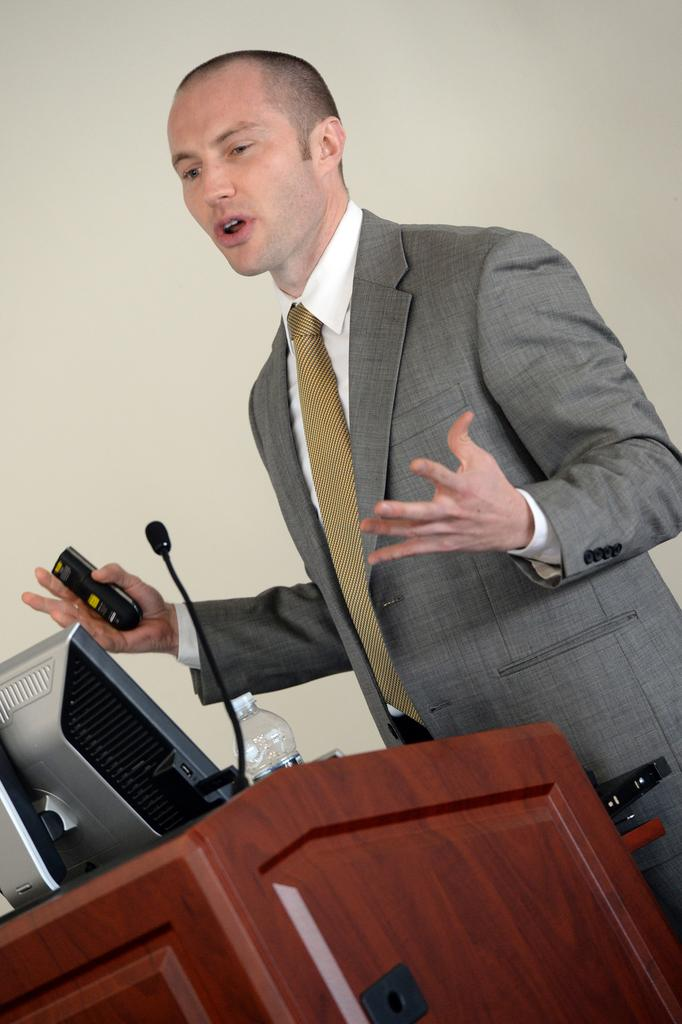What is the person in the image wearing? The person is wearing clothes in the image. Where is the person standing in relation to the podium? The person is standing in front of a podium. What items can be seen on the podium? The podium contains a bottle, mic, and monitor. What is the person holding in their hand? The person is holding a remote in their hand. How many eyes can be seen on the jellyfish in the image? There is no jellyfish present in the image, so it is not possible to determine the number of eyes. 